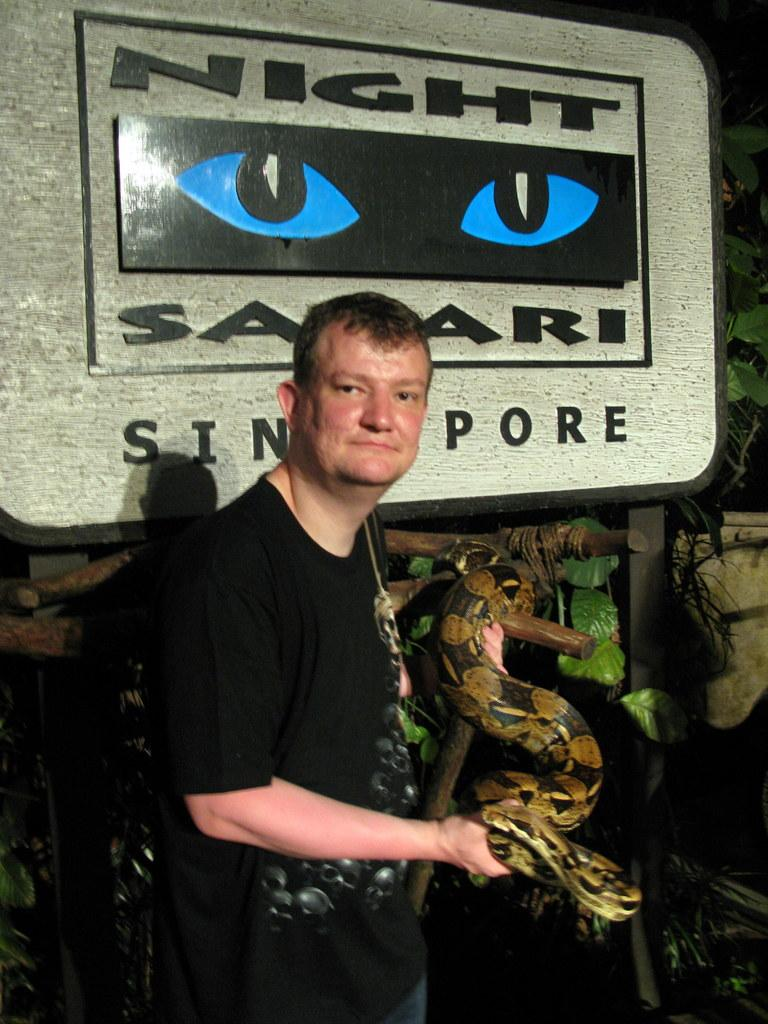What is the person in the image wearing? The person is wearing a black t-shirt. What is the person holding in his hand? The person is holding a snake in his hand. What can be seen on the board in the image? The board in the image has the text "Night Safari Singapore" written on it. What type of vegetation is visible in the background of the image? There are plants visible in the background of the image. What type of food is being prepared on the stone in the image? There is no stone or food preparation visible in the image. How many pails are present in the image? There are no pails present in the image. 